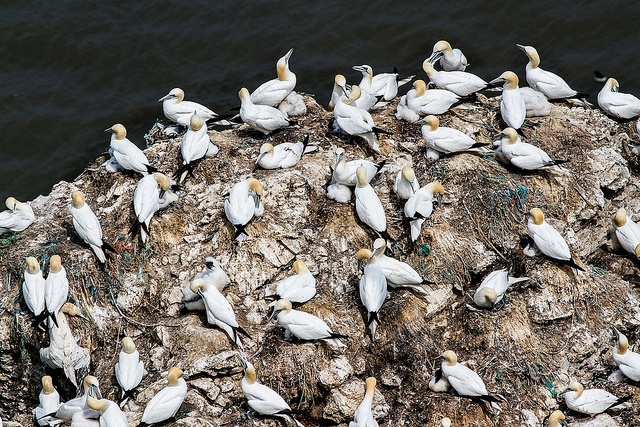Describe the objects in this image and their specific colors. I can see bird in black, lightgray, darkgray, and gray tones, bird in black, lightgray, darkgray, and gray tones, bird in black, lightgray, darkgray, and gray tones, bird in black, lightgray, darkgray, and gray tones, and bird in black, lightgray, darkgray, and tan tones in this image. 